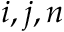<formula> <loc_0><loc_0><loc_500><loc_500>i , j , n</formula> 